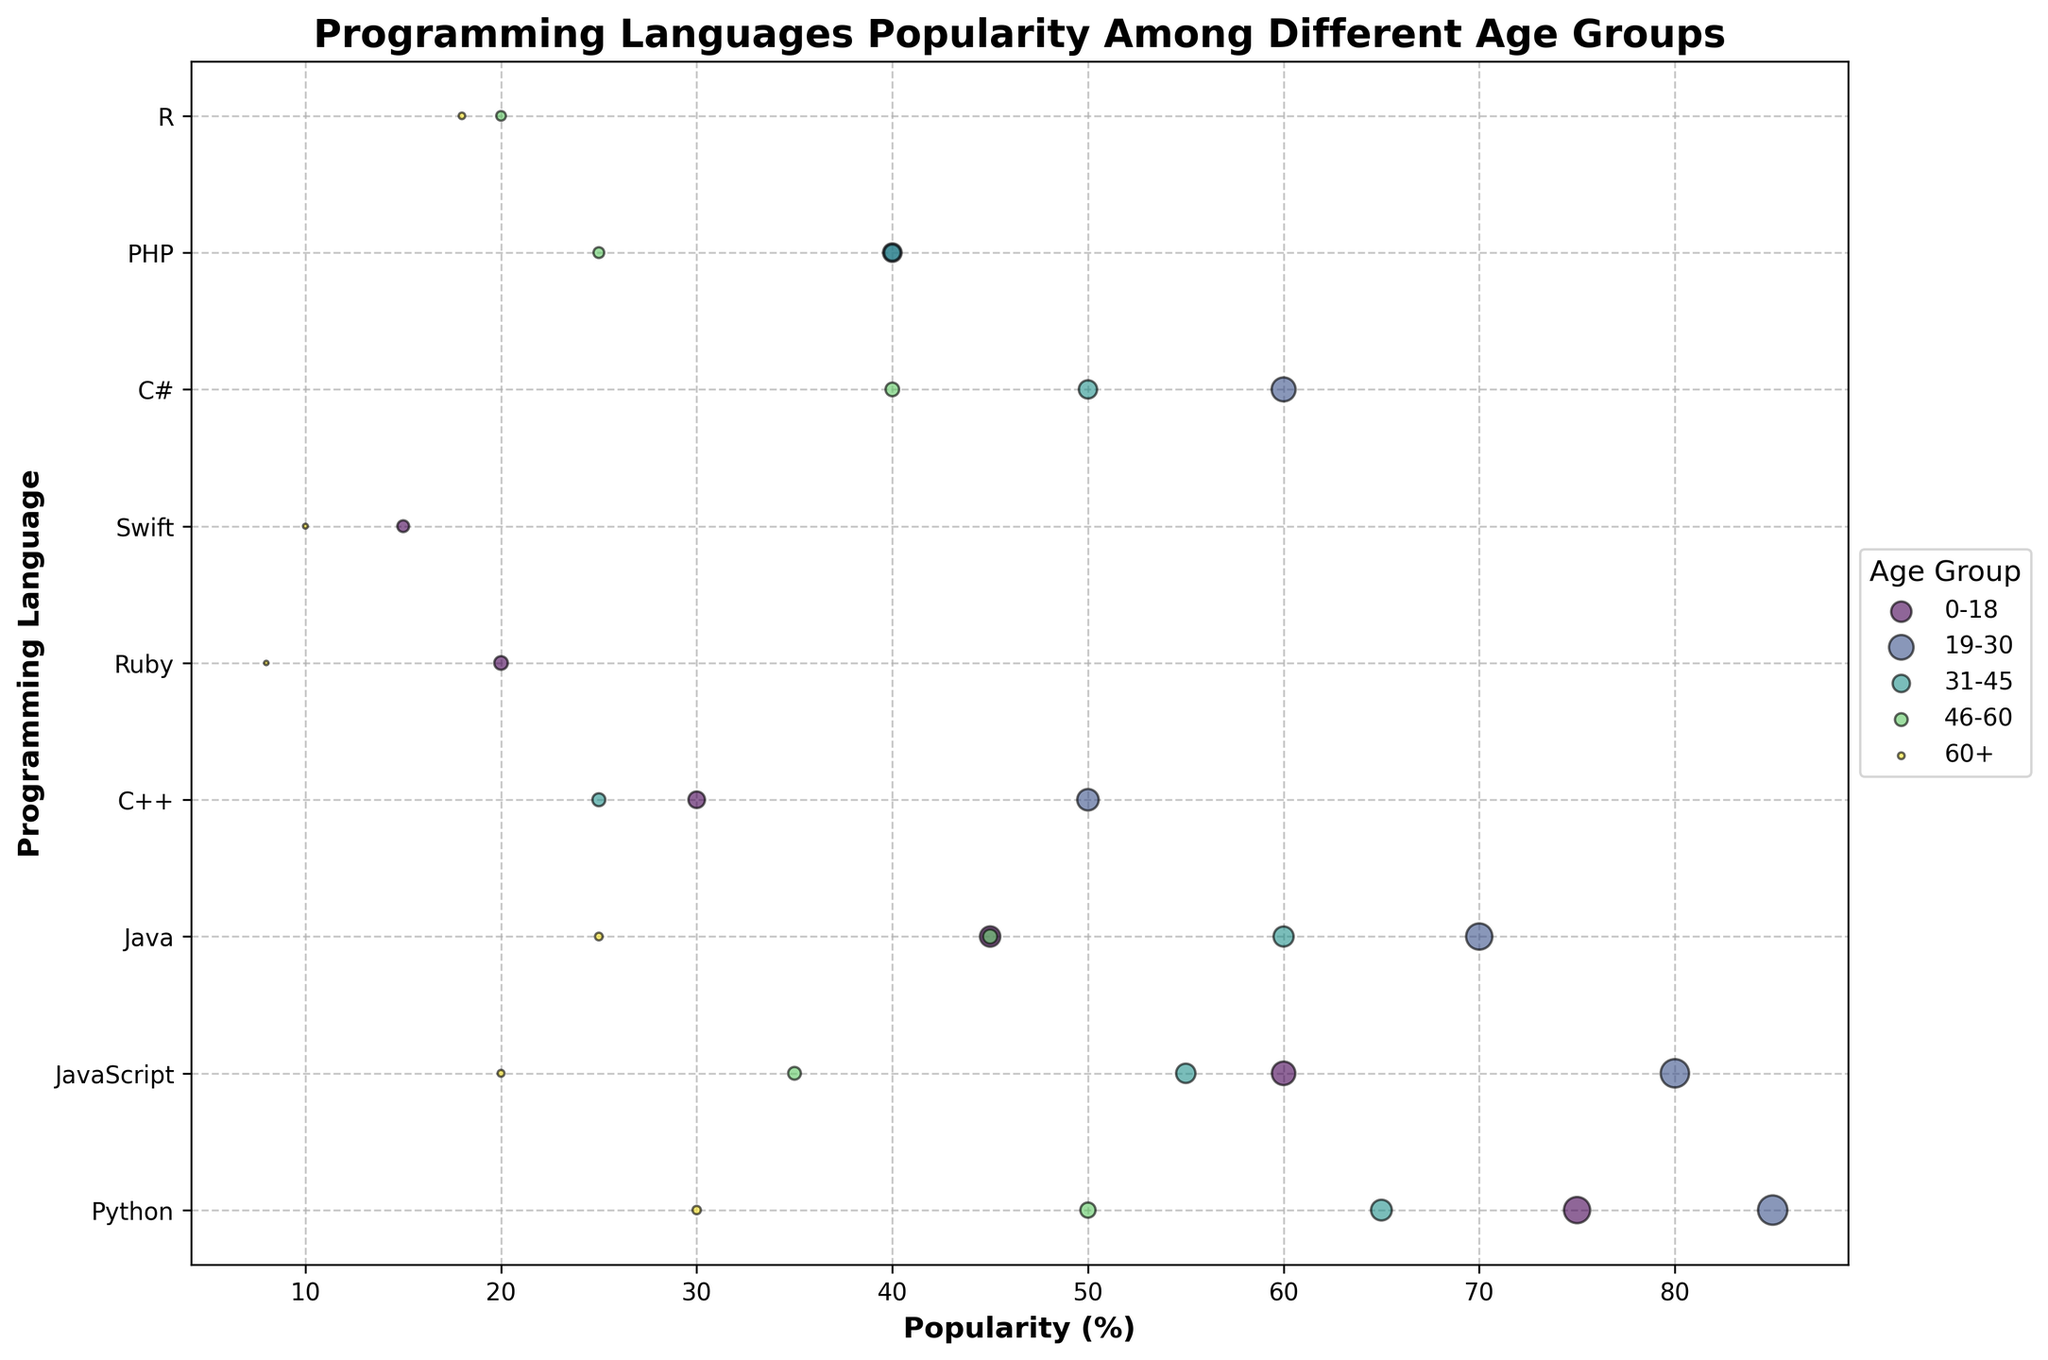What is the title of the figure? The title of the figure is usually prominently shown at the top. Here, it reads "Programming Languages Popularity Among Different Age Groups" which indicates the overall subject of the chart.
Answer: Programming Languages Popularity Among Different Age Groups Which age group has the highest popularity for Python? To determine which age group has the highest popularity for Python, we look at the position of the bubbles along the X-axis where the labels correspond to age groups. The highest value on the X-axis for Python is in the 19-30 age group with a popularity of 85%.
Answer: 19-30 Between the age groups 0-18 and 31-45, which programming language has the greatest difference in popularity? Comparing the two age groups, we calculate the difference in popularity for each programming language and see that for both Python (75% and 65%) and JavaScript (60% and 55%) the difference is not as much as Java (45% and 60%), which has a difference of 15%.
Answer: Java How does the number of users change for Python from the 0-18 age group to the 19-30 age group? To see the change in the number of users, we compare the sizes of the bubbles. For the 0-18 group, Python has 12,000 users; for the 19-30 group, it has 15,000 users. The change is 15,000 - 12,000 = 3,000.
Answer: Increases by 3,000 Which programming language shows a significant drop in popularity for users aged 60+ compared to 46-60? By comparing bubbles for users aged 60+ and 46-60, PHP shows a significant drop with 25% in 46-60 and 0% in the 60+ group, which isn't even present on this list. This indicates sharp decline for PHP.
Answer: PHP Are there any programming languages that are popular across all age groups? By observing the appearance of bubbles across all age groups, we can see that Python, Java, and JavaScript have bubbles (indicating user popularity) across all age groups, indicating consistent popularity.
Answer: Python, Java, JavaScript Which programming language in the 46-60 age group has a number of users close to 1,600 and what is its popularity? Looking at the sizes of the bubbles and the transparency level, R in the 46-60 age group has about 1,600 users, and it shows a popularity of 20%.
Answer: R, 20% What is the average popularity for JavaScript across all age groups? To find the average popularity of JavaScript, add the popularity percentages across all age groups and divide by the number of age groups: (60 + 80 + 55 + 35 + 20) / 5 = 50.
Answer: 50 Which programming language has the smallest bubble size in the 60+ age group, and what does that indicate about its user base? Observing the bubble sizes in the 60+ age group, Ruby has the smallest size, indicating the lowest number of users (320 users).
Answer: Ruby, Small user base Are there any age groups where two programming languages have equal popularity? Examining the X-axis values across age groups, for the 19-30 age group, Python and JavaScript are both popular with values of 85% and 80% respectively, which are quite close. But in the 31-45 group, Java and C# have close popularities with 60% and 50% respectively.
Answer: Java and C# in 31-45 